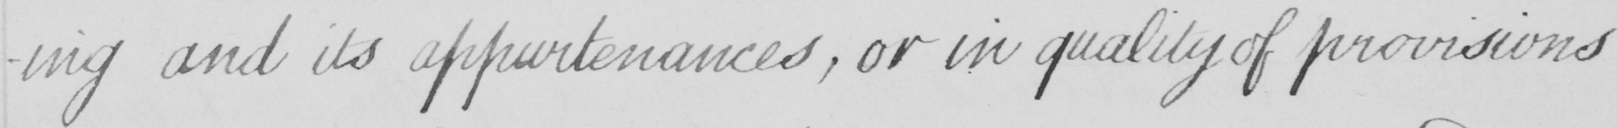Can you tell me what this handwritten text says? -ing and its appurtenances , or in quality of provisions 